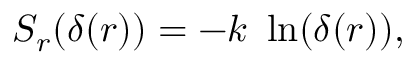Convert formula to latex. <formula><loc_0><loc_0><loc_500><loc_500>S _ { r } ( \delta ( r ) ) = - k \ \ln ( \delta ( r ) ) ,</formula> 